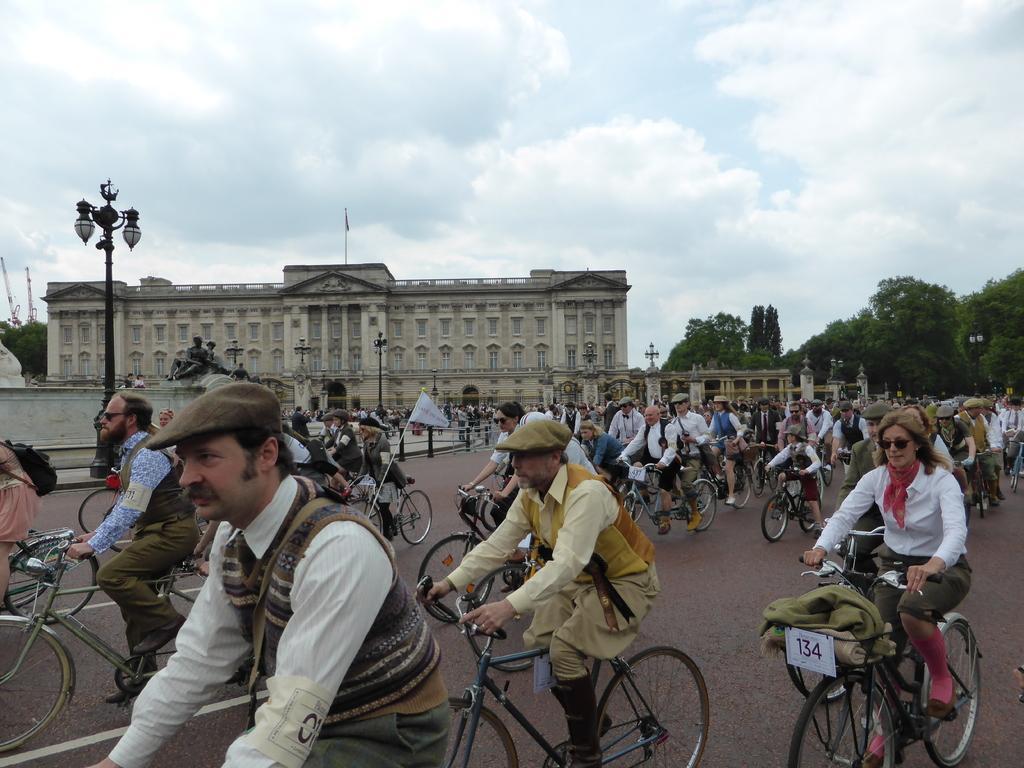Please provide a concise description of this image. In this picture many people are cycling. In the background there is a building. And there is a cloudy sky. And to the right corner there are some trees. And to the left there is a pole with the lamps. 